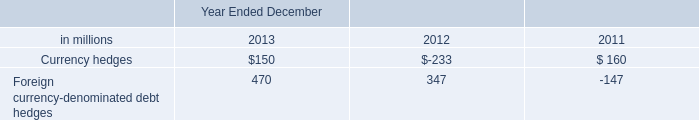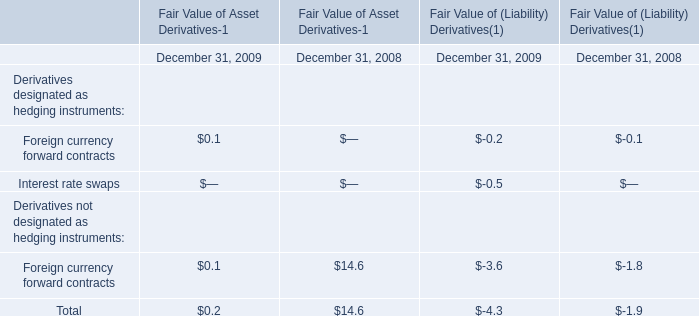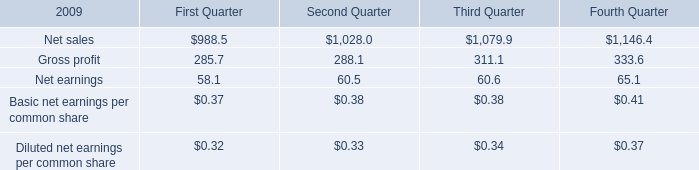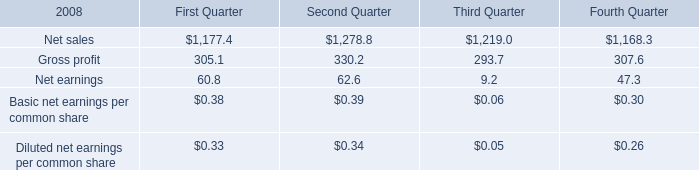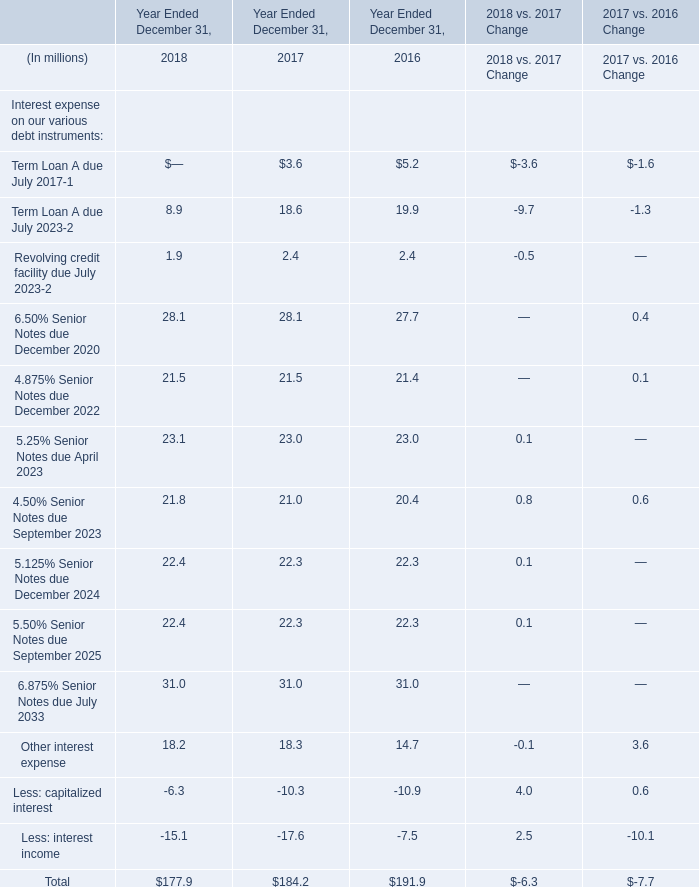What will Other interest expense be like in 2019 Ended December 31 if it develops with the same growing rate as in 2018 Ended December 31? (in million) 
Computations: (18.2 * (1 + ((18.2 - 18.3) / 18.3)))
Answer: 18.10055. 